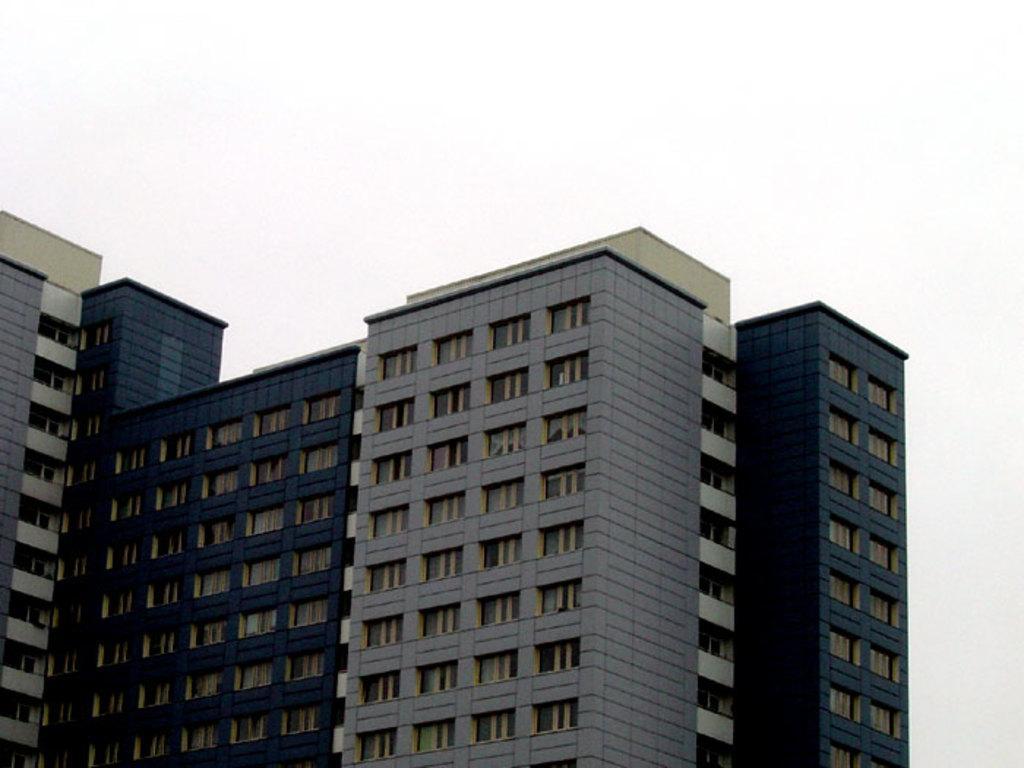Can you describe this image briefly? Here we can see buildings. There is a white background. 